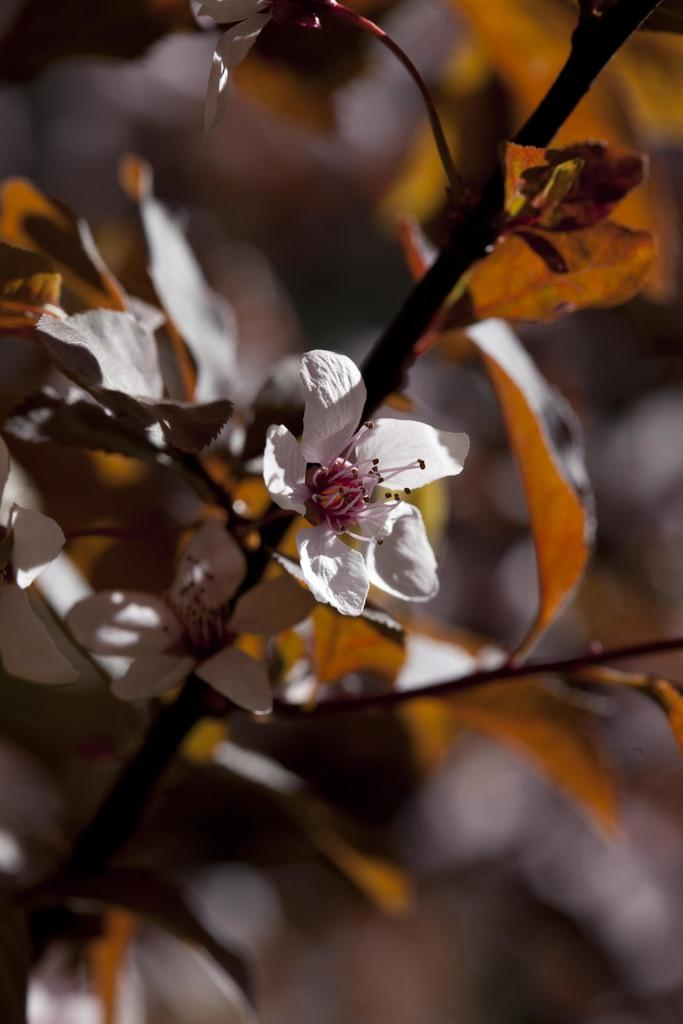What type of flower is in the picture? There is a white flower in the picture. What parts of the flower can be seen? The flower has a stem and leaves associated with it. How is the background of the image depicted? The backdrop of the image is blurred. What language is the flower speaking in the image? Flowers do not speak, so there is no language present in the image. 